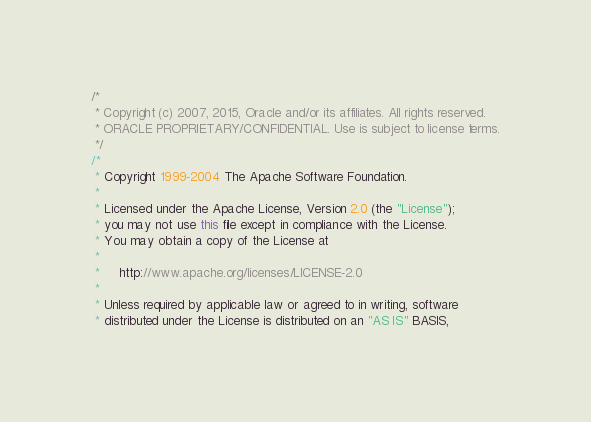<code> <loc_0><loc_0><loc_500><loc_500><_Java_>/*
 * Copyright (c) 2007, 2015, Oracle and/or its affiliates. All rights reserved.
 * ORACLE PROPRIETARY/CONFIDENTIAL. Use is subject to license terms.
 */
/*
 * Copyright 1999-2004 The Apache Software Foundation.
 *
 * Licensed under the Apache License, Version 2.0 (the "License");
 * you may not use this file except in compliance with the License.
 * You may obtain a copy of the License at
 *
 *     http://www.apache.org/licenses/LICENSE-2.0
 *
 * Unless required by applicable law or agreed to in writing, software
 * distributed under the License is distributed on an "AS IS" BASIS,</code> 